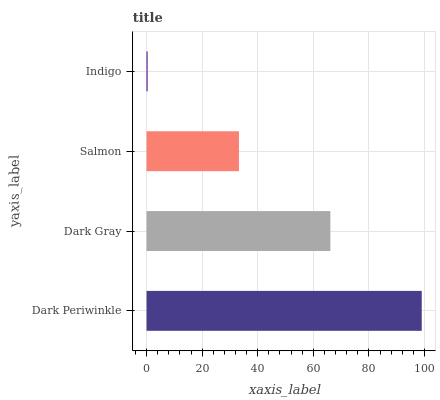Is Indigo the minimum?
Answer yes or no. Yes. Is Dark Periwinkle the maximum?
Answer yes or no. Yes. Is Dark Gray the minimum?
Answer yes or no. No. Is Dark Gray the maximum?
Answer yes or no. No. Is Dark Periwinkle greater than Dark Gray?
Answer yes or no. Yes. Is Dark Gray less than Dark Periwinkle?
Answer yes or no. Yes. Is Dark Gray greater than Dark Periwinkle?
Answer yes or no. No. Is Dark Periwinkle less than Dark Gray?
Answer yes or no. No. Is Dark Gray the high median?
Answer yes or no. Yes. Is Salmon the low median?
Answer yes or no. Yes. Is Salmon the high median?
Answer yes or no. No. Is Dark Gray the low median?
Answer yes or no. No. 